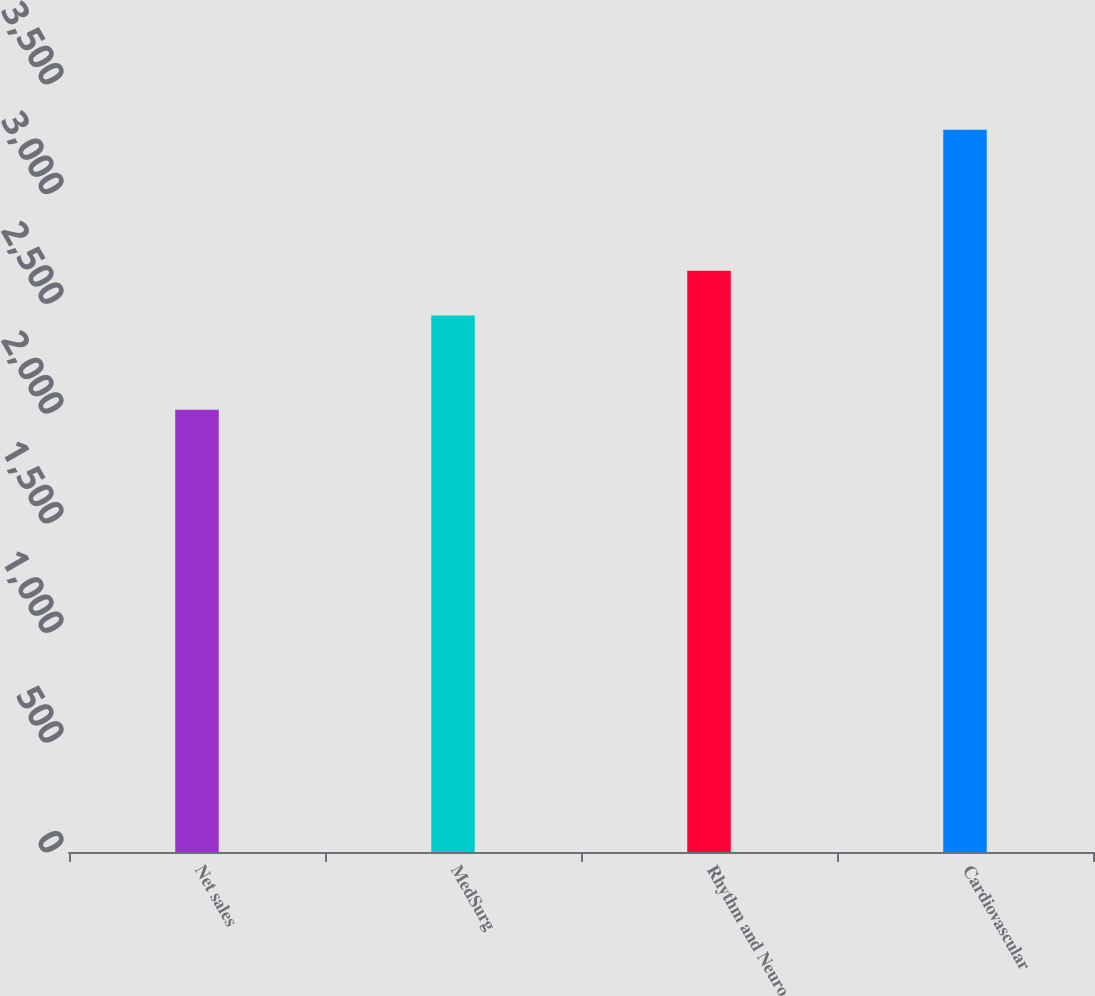Convert chart. <chart><loc_0><loc_0><loc_500><loc_500><bar_chart><fcel>Net sales<fcel>MedSurg<fcel>Rhythm and Neuro<fcel>Cardiovascular<nl><fcel>2016<fcel>2445<fcel>2649<fcel>3292<nl></chart> 